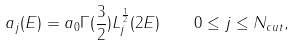Convert formula to latex. <formula><loc_0><loc_0><loc_500><loc_500>a _ { j } ( E ) = a _ { 0 } \Gamma ( \frac { 3 } { 2 } ) L ^ { \frac { 1 } { 2 } } _ { j } ( 2 E ) \quad 0 \leq j \leq N _ { c u t } ,</formula> 